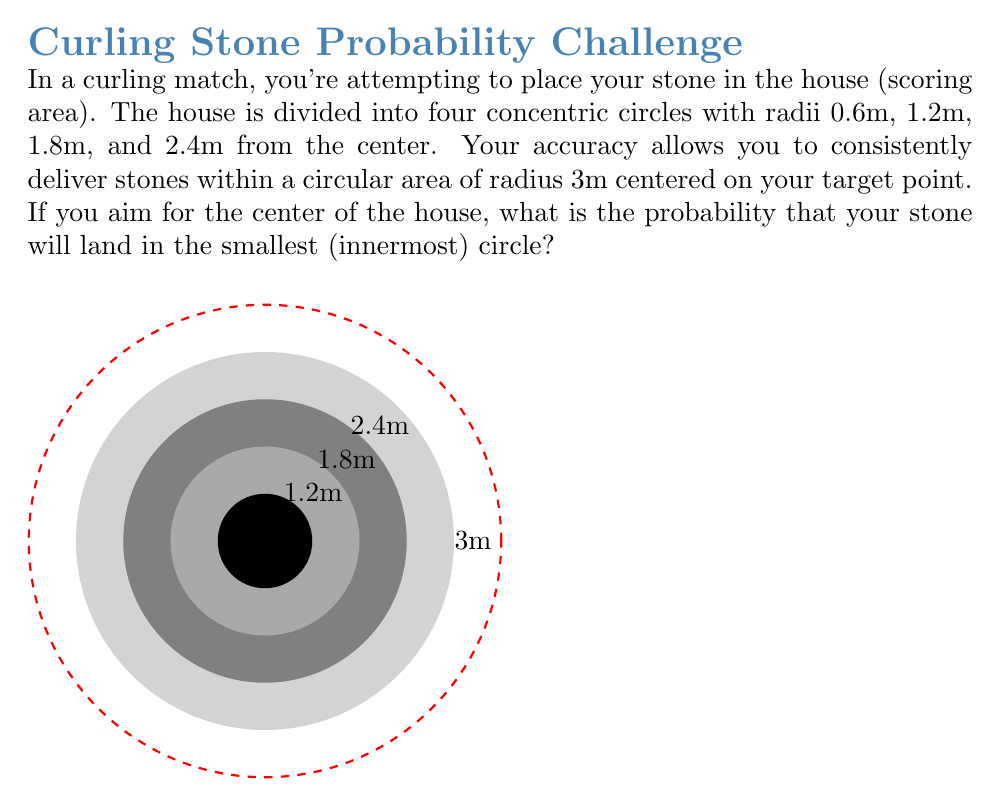What is the answer to this math problem? Let's approach this step-by-step:

1) The probability of the stone landing in the smallest circle is the ratio of the area of the smallest circle to the total area where the stone could land.

2) The area of the smallest circle (target area):
   $$A_{target} = \pi r^2 = \pi (0.6m)^2 = 0.36\pi m^2$$

3) The total area where the stone could land (your accuracy area):
   $$A_{total} = \pi R^2 = \pi (3m)^2 = 9\pi m^2$$

4) The probability is therefore:
   $$P = \frac{A_{target}}{A_{total}} = \frac{0.36\pi m^2}{9\pi m^2} = \frac{0.36}{9} = 0.04$$

5) To express this as a percentage:
   $$0.04 \times 100\% = 4\%$$

Thus, there is a 4% chance that your stone will land in the smallest circle when aiming for the center of the house.
Answer: 4% 